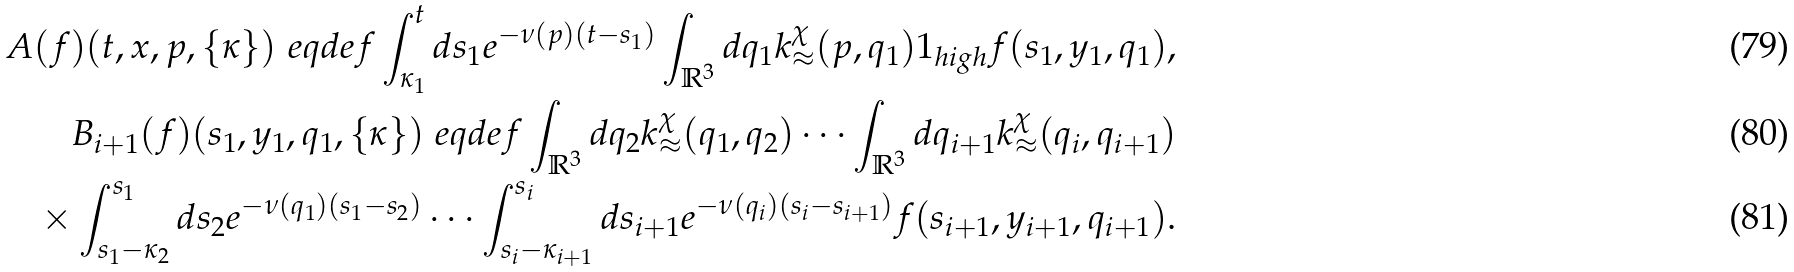<formula> <loc_0><loc_0><loc_500><loc_500>A ( f ) ( t , x , p , \{ \kappa \} ) \ e q d e f \int _ { \kappa _ { 1 } } ^ { t } d s _ { 1 } e ^ { - \nu ( p ) ( t - s _ { 1 } ) } \int _ { \mathbb { R } ^ { 3 } } d q _ { 1 } k _ { \approx } ^ { \chi } ( p , q _ { 1 } ) { 1 } _ { h i g h } f ( s _ { 1 } , y _ { 1 } , q _ { 1 } ) , \\ B _ { i + 1 } ( f ) ( s _ { 1 } , y _ { 1 } , q _ { 1 } , \{ \kappa \} ) \ e q d e f \int _ { \mathbb { R } ^ { 3 } } d q _ { 2 } k _ { \approx } ^ { \chi } ( q _ { 1 } , q _ { 2 } ) \cdots \int _ { \mathbb { R } ^ { 3 } } d q _ { i + 1 } k _ { \approx } ^ { \chi } ( q _ { i } , q _ { i + 1 } ) \\ \times \int _ { s _ { 1 } - \kappa _ { 2 } } ^ { s _ { 1 } } d s _ { 2 } e ^ { - \nu ( q _ { 1 } ) ( s _ { 1 } - s _ { 2 } ) } \cdots \int _ { s _ { i } - \kappa _ { i + 1 } } ^ { s _ { i } } d s _ { i + 1 } e ^ { - \nu ( q _ { i } ) ( s _ { i } - s _ { i + 1 } ) } f ( s _ { i + 1 } , y _ { i + 1 } , q _ { i + 1 } ) .</formula> 